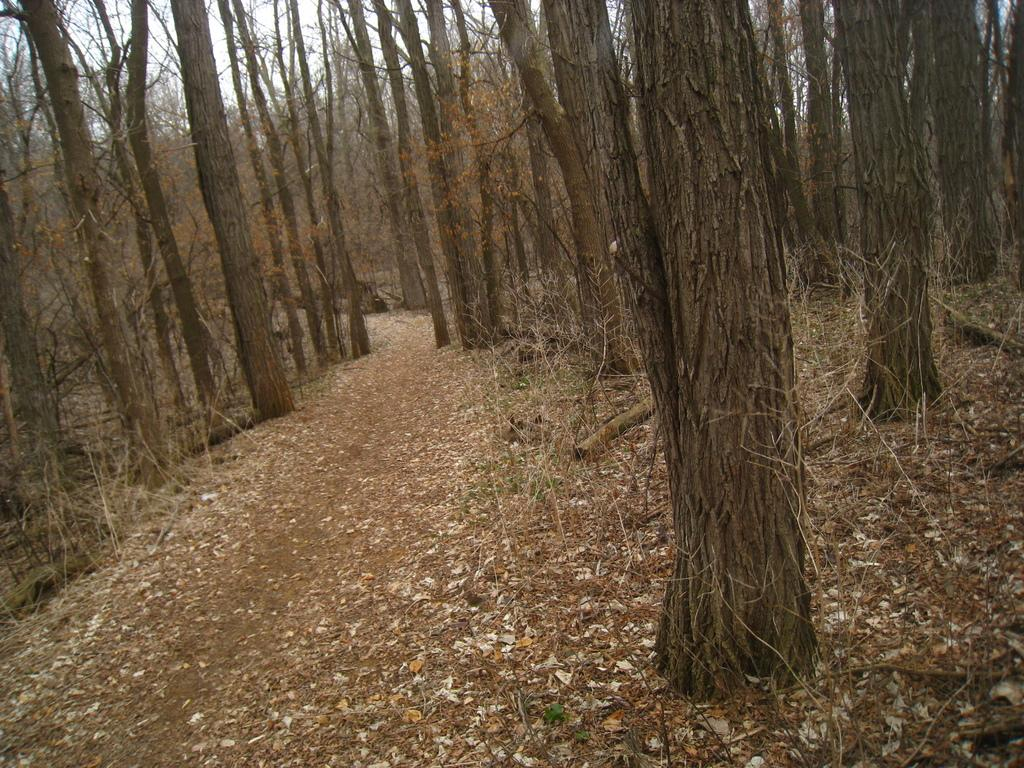What can be seen in the foreground of the image? There is a path in the foreground of the image. What is located on the other side of the path? There are trees on the other side of the path. What is visible in the background of the image? The sky is visible in the background of the image. What type of wren can be seen perched on the structure in the image? There is no wren or structure present in the image. 